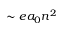<formula> <loc_0><loc_0><loc_500><loc_500>\sim e a _ { 0 } n ^ { 2 }</formula> 